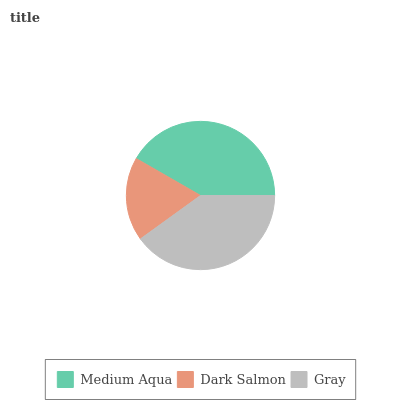Is Dark Salmon the minimum?
Answer yes or no. Yes. Is Medium Aqua the maximum?
Answer yes or no. Yes. Is Gray the minimum?
Answer yes or no. No. Is Gray the maximum?
Answer yes or no. No. Is Gray greater than Dark Salmon?
Answer yes or no. Yes. Is Dark Salmon less than Gray?
Answer yes or no. Yes. Is Dark Salmon greater than Gray?
Answer yes or no. No. Is Gray less than Dark Salmon?
Answer yes or no. No. Is Gray the high median?
Answer yes or no. Yes. Is Gray the low median?
Answer yes or no. Yes. Is Medium Aqua the high median?
Answer yes or no. No. Is Medium Aqua the low median?
Answer yes or no. No. 